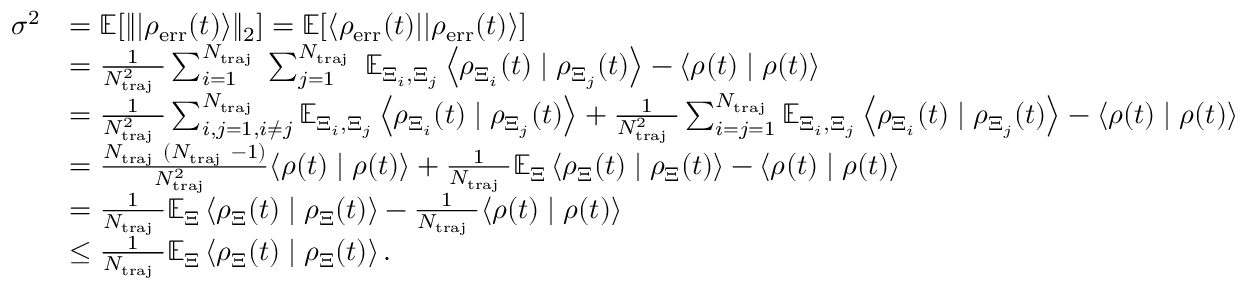Convert formula to latex. <formula><loc_0><loc_0><loc_500><loc_500>\begin{array} { r l } { \sigma ^ { 2 } } & { = \mathbb { E } [ \| | \rho _ { e r r } ( t ) \rangle \| _ { 2 } ] = \mathbb { E } [ \langle \rho _ { e r r } ( t ) | | \rho _ { e r r } ( t ) \rangle ] } \\ & { = \frac { 1 } { N _ { t r a j } ^ { 2 } } \sum _ { i = 1 } ^ { N _ { t r a j } } \sum _ { j = 1 } ^ { N _ { t r a j } } \mathbb { E } _ { \Xi _ { i } , \Xi _ { j } } \left \langle \rho _ { \Xi _ { i } } ( t ) | \rho _ { \Xi _ { j } } ( t ) \right \rangle - \langle \rho ( t ) | \rho ( t ) \rangle } \\ & { = \frac { 1 } { N _ { t r a j } ^ { 2 } } \sum _ { i , j = 1 , i \neq j } ^ { N _ { t r a j } } \mathbb { E } _ { \Xi _ { i } , \Xi _ { j } } \left \langle \rho _ { \Xi _ { i } } ( t ) | \rho _ { \Xi _ { j } } ( t ) \right \rangle + \frac { 1 } { N _ { t r a j } ^ { 2 } } \sum _ { i = j = 1 } ^ { N _ { t r a j } } \mathbb { E } _ { \Xi _ { i } , \Xi _ { j } } \left \langle \rho _ { \Xi _ { i } } ( t ) | \rho _ { \Xi _ { j } } ( t ) \right \rangle - \langle \rho ( t ) | \rho ( t ) \rangle } \\ & { = \frac { N _ { t r a j } ( N _ { t r a j } - 1 ) } { N _ { t r a j } ^ { 2 } } \langle \rho ( t ) | \rho ( t ) \rangle + \frac { 1 } { N _ { t r a j } } \mathbb { E } _ { \Xi } \left \langle \rho _ { \Xi } ( t ) | \rho _ { \Xi } ( t ) \right \rangle - \langle \rho ( t ) | \rho ( t ) \rangle } \\ & { = \frac { 1 } { N _ { t r a j } } \mathbb { E } _ { \Xi } \left \langle \rho _ { \Xi } ( t ) | \rho _ { \Xi } ( t ) \right \rangle - \frac { 1 } { N _ { t r a j } } \langle \rho ( t ) | \rho ( t ) \rangle } \\ & { \leq \frac { 1 } { N _ { t r a j } } \mathbb { E } _ { \Xi } \left \langle \rho _ { \Xi } ( t ) | \rho _ { \Xi } ( t ) \right \rangle . } \end{array}</formula> 